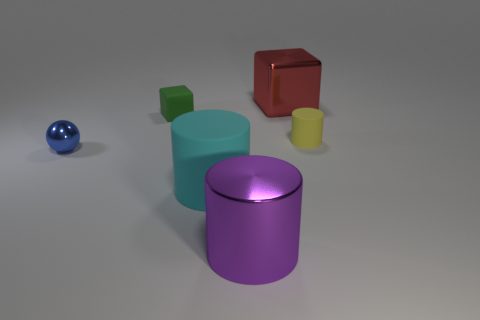Add 3 red blocks. How many objects exist? 9 Subtract all cubes. How many objects are left? 4 Subtract 0 purple cubes. How many objects are left? 6 Subtract all yellow matte cylinders. Subtract all tiny blue shiny spheres. How many objects are left? 4 Add 5 large matte objects. How many large matte objects are left? 6 Add 2 big cyan matte things. How many big cyan matte things exist? 3 